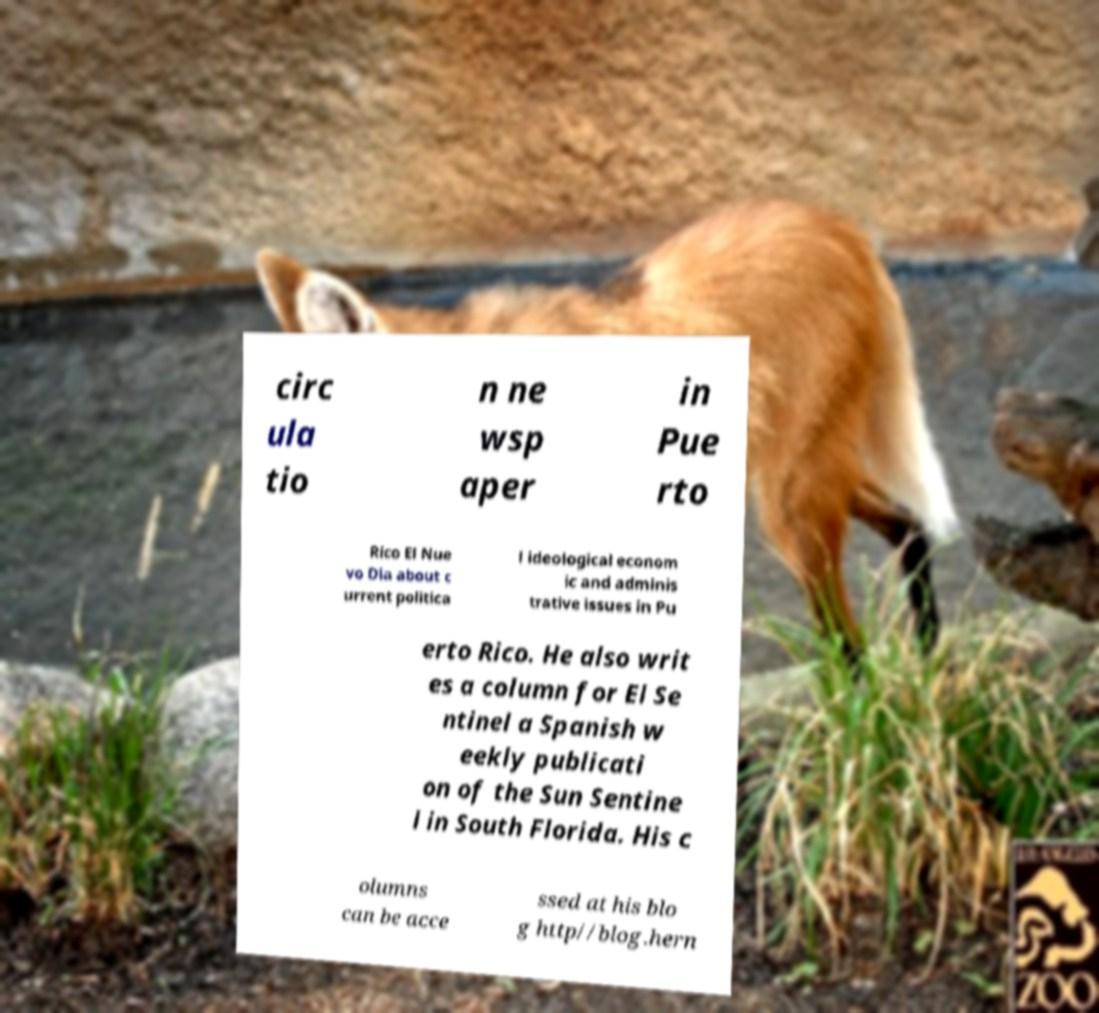Can you accurately transcribe the text from the provided image for me? circ ula tio n ne wsp aper in Pue rto Rico El Nue vo Dia about c urrent politica l ideological econom ic and adminis trative issues in Pu erto Rico. He also writ es a column for El Se ntinel a Spanish w eekly publicati on of the Sun Sentine l in South Florida. His c olumns can be acce ssed at his blo g http//blog.hern 